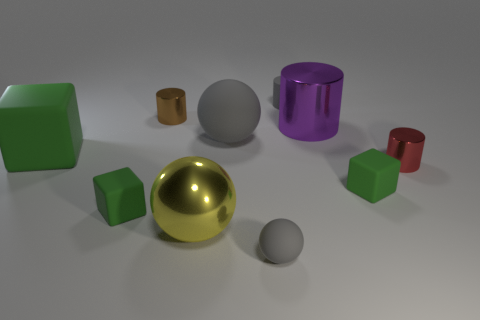Subtract all green cubes. How many were subtracted if there are1green cubes left? 2 Subtract 1 brown cylinders. How many objects are left? 9 Subtract all balls. How many objects are left? 7 Subtract all small gray matte cylinders. Subtract all tiny blue matte cylinders. How many objects are left? 9 Add 5 large gray objects. How many large gray objects are left? 6 Add 6 green cubes. How many green cubes exist? 9 